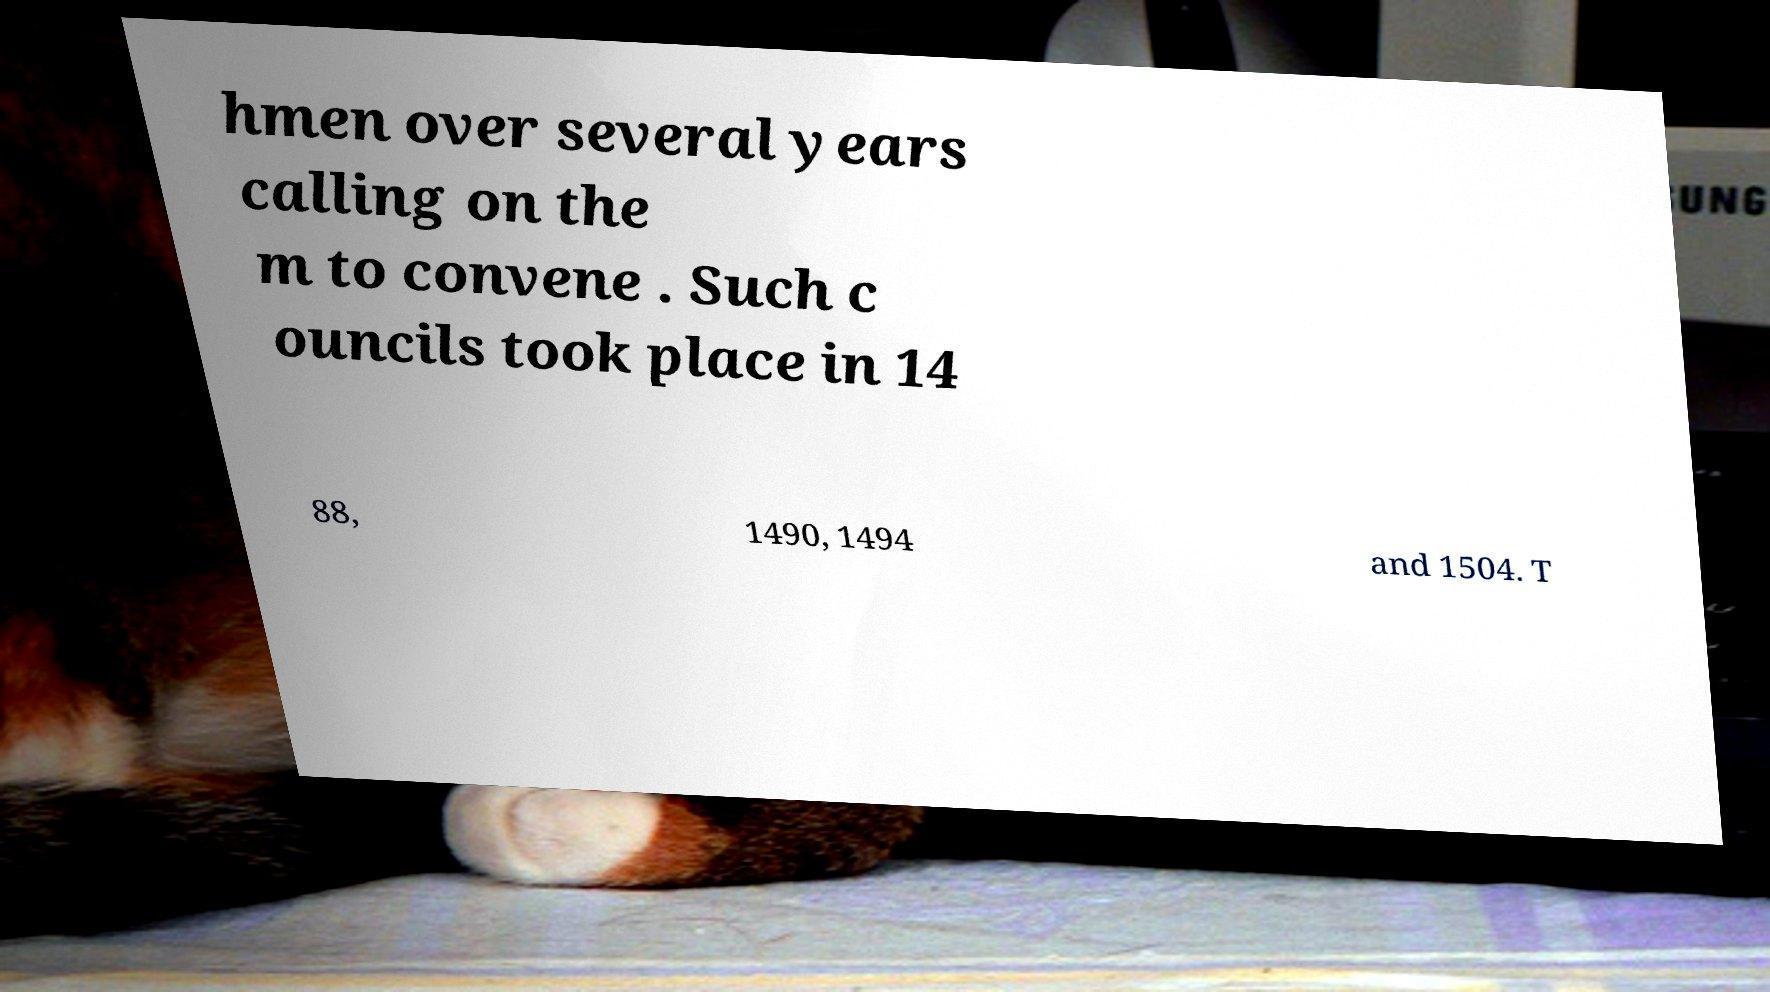There's text embedded in this image that I need extracted. Can you transcribe it verbatim? hmen over several years calling on the m to convene . Such c ouncils took place in 14 88, 1490, 1494 and 1504. T 